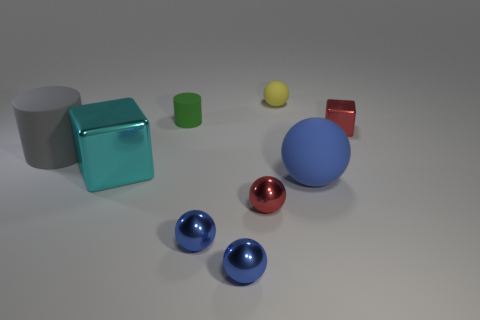How many objects in this image could feasibly float in water? Based on their appearance, the small rubber cylinder and the yellow ball might be capable of floating due to their materials' natural buoyancy. 